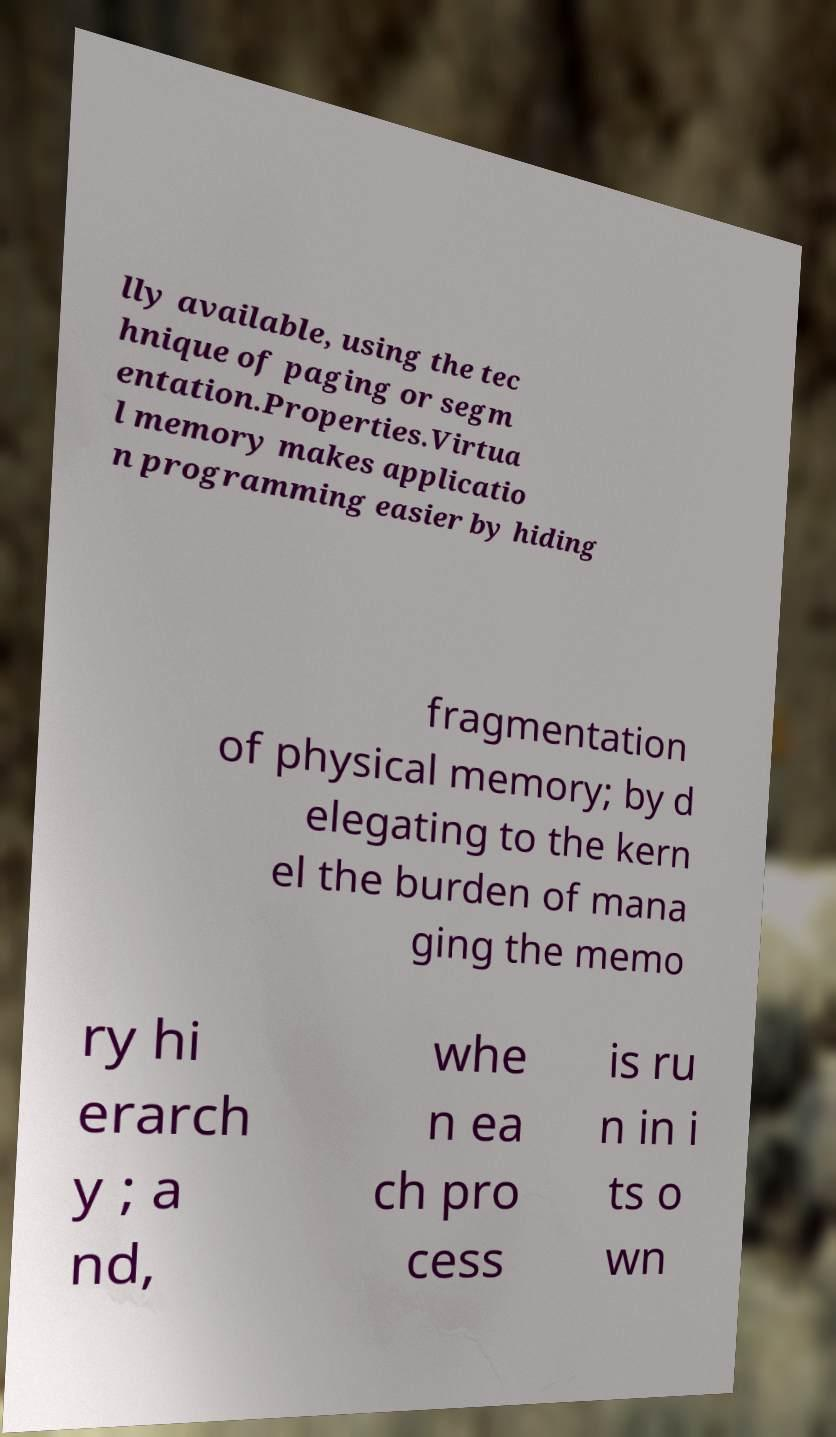Can you accurately transcribe the text from the provided image for me? lly available, using the tec hnique of paging or segm entation.Properties.Virtua l memory makes applicatio n programming easier by hiding fragmentation of physical memory; by d elegating to the kern el the burden of mana ging the memo ry hi erarch y ; a nd, whe n ea ch pro cess is ru n in i ts o wn 